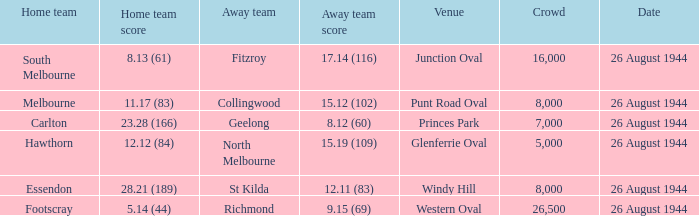What is the average number of attendees when the home team is melbourne? 8000.0. 